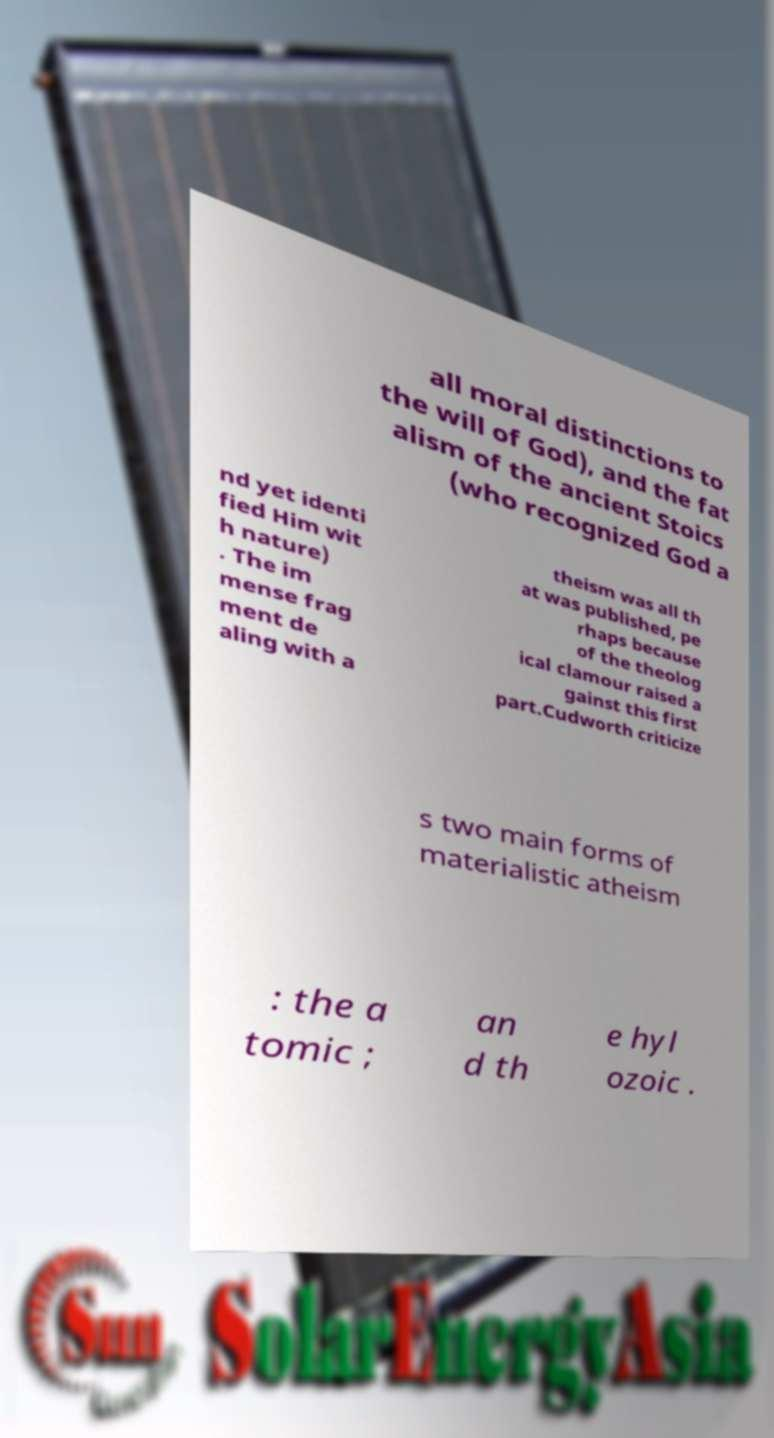What messages or text are displayed in this image? I need them in a readable, typed format. all moral distinctions to the will of God), and the fat alism of the ancient Stoics (who recognized God a nd yet identi fied Him wit h nature) . The im mense frag ment de aling with a theism was all th at was published, pe rhaps because of the theolog ical clamour raised a gainst this first part.Cudworth criticize s two main forms of materialistic atheism : the a tomic ; an d th e hyl ozoic . 